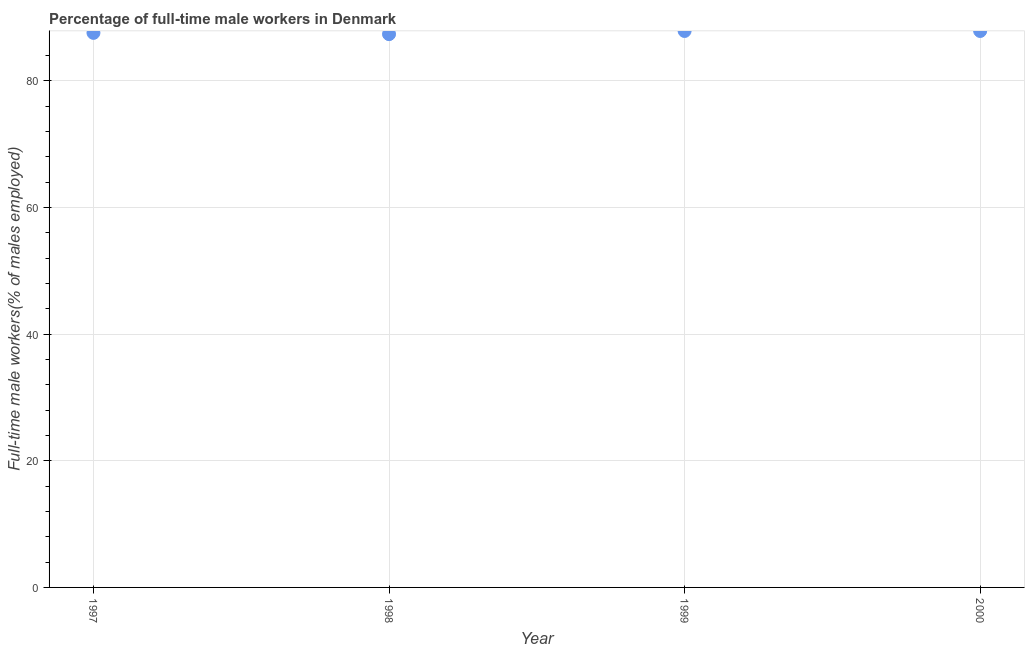What is the percentage of full-time male workers in 1999?
Offer a very short reply. 87.9. Across all years, what is the maximum percentage of full-time male workers?
Offer a very short reply. 87.9. Across all years, what is the minimum percentage of full-time male workers?
Make the answer very short. 87.4. In which year was the percentage of full-time male workers maximum?
Your response must be concise. 1999. In which year was the percentage of full-time male workers minimum?
Your response must be concise. 1998. What is the sum of the percentage of full-time male workers?
Offer a very short reply. 350.8. What is the average percentage of full-time male workers per year?
Provide a succinct answer. 87.7. What is the median percentage of full-time male workers?
Your response must be concise. 87.75. What is the ratio of the percentage of full-time male workers in 1997 to that in 1999?
Keep it short and to the point. 1. Is the percentage of full-time male workers in 1997 less than that in 1999?
Your answer should be compact. Yes. Is the difference between the percentage of full-time male workers in 1998 and 1999 greater than the difference between any two years?
Your answer should be very brief. Yes. What is the difference between the highest and the second highest percentage of full-time male workers?
Provide a short and direct response. 0. In how many years, is the percentage of full-time male workers greater than the average percentage of full-time male workers taken over all years?
Make the answer very short. 2. What is the difference between two consecutive major ticks on the Y-axis?
Provide a short and direct response. 20. Does the graph contain any zero values?
Offer a terse response. No. What is the title of the graph?
Give a very brief answer. Percentage of full-time male workers in Denmark. What is the label or title of the X-axis?
Offer a very short reply. Year. What is the label or title of the Y-axis?
Your answer should be very brief. Full-time male workers(% of males employed). What is the Full-time male workers(% of males employed) in 1997?
Your response must be concise. 87.6. What is the Full-time male workers(% of males employed) in 1998?
Provide a short and direct response. 87.4. What is the Full-time male workers(% of males employed) in 1999?
Your answer should be compact. 87.9. What is the Full-time male workers(% of males employed) in 2000?
Offer a very short reply. 87.9. What is the difference between the Full-time male workers(% of males employed) in 1997 and 1998?
Your response must be concise. 0.2. What is the difference between the Full-time male workers(% of males employed) in 1997 and 1999?
Keep it short and to the point. -0.3. What is the difference between the Full-time male workers(% of males employed) in 1997 and 2000?
Provide a succinct answer. -0.3. What is the difference between the Full-time male workers(% of males employed) in 1998 and 1999?
Keep it short and to the point. -0.5. What is the difference between the Full-time male workers(% of males employed) in 1998 and 2000?
Provide a succinct answer. -0.5. What is the ratio of the Full-time male workers(% of males employed) in 1997 to that in 2000?
Make the answer very short. 1. What is the ratio of the Full-time male workers(% of males employed) in 1999 to that in 2000?
Offer a very short reply. 1. 